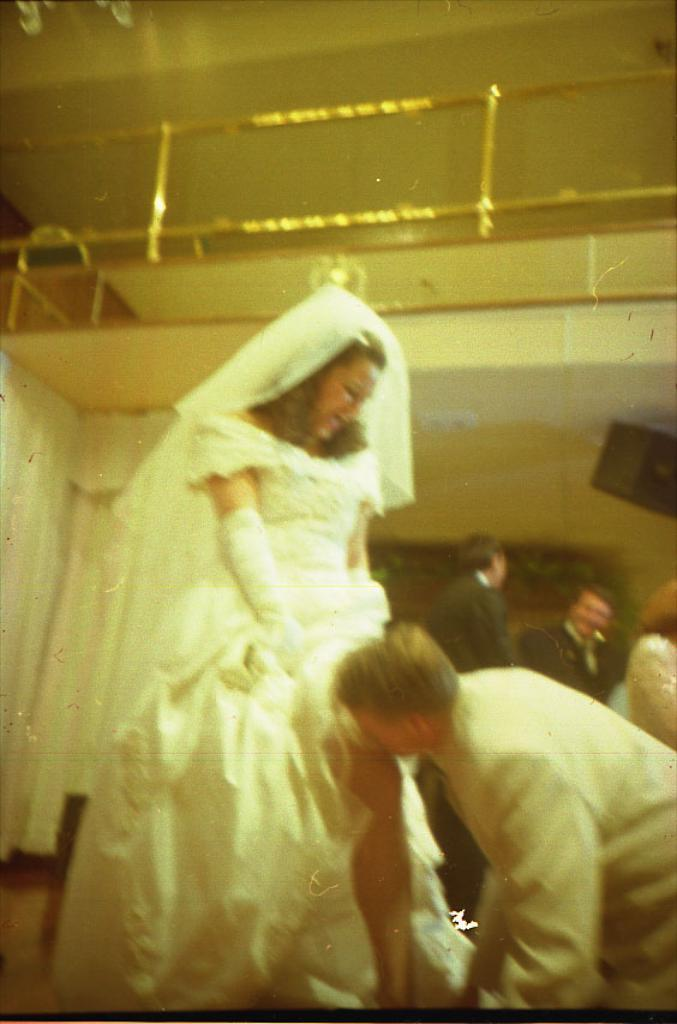How many people are in the image? There is a group of people in the image. What colors are the people wearing? The people are wearing white and black color dresses. What can be seen in the background of the image? There are curtains and railing visible in the background of the image. Are the people in the image participating in a religious ceremony? There is no indication of a religious ceremony in the image; the people are simply wearing white and black color dresses. Is there a fight happening between the people in the image? There is no fight depicted in the image; the people are standing together in a group. 